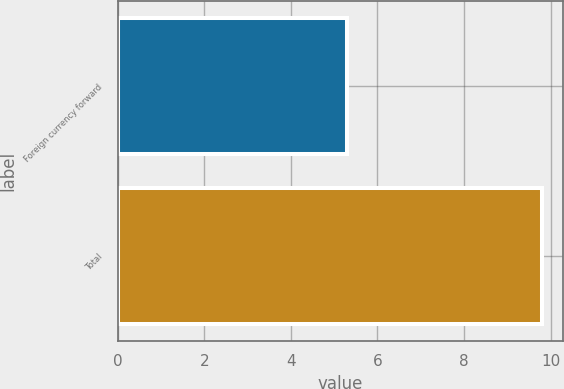Convert chart. <chart><loc_0><loc_0><loc_500><loc_500><bar_chart><fcel>Foreign currency forward<fcel>Total<nl><fcel>5.3<fcel>9.8<nl></chart> 